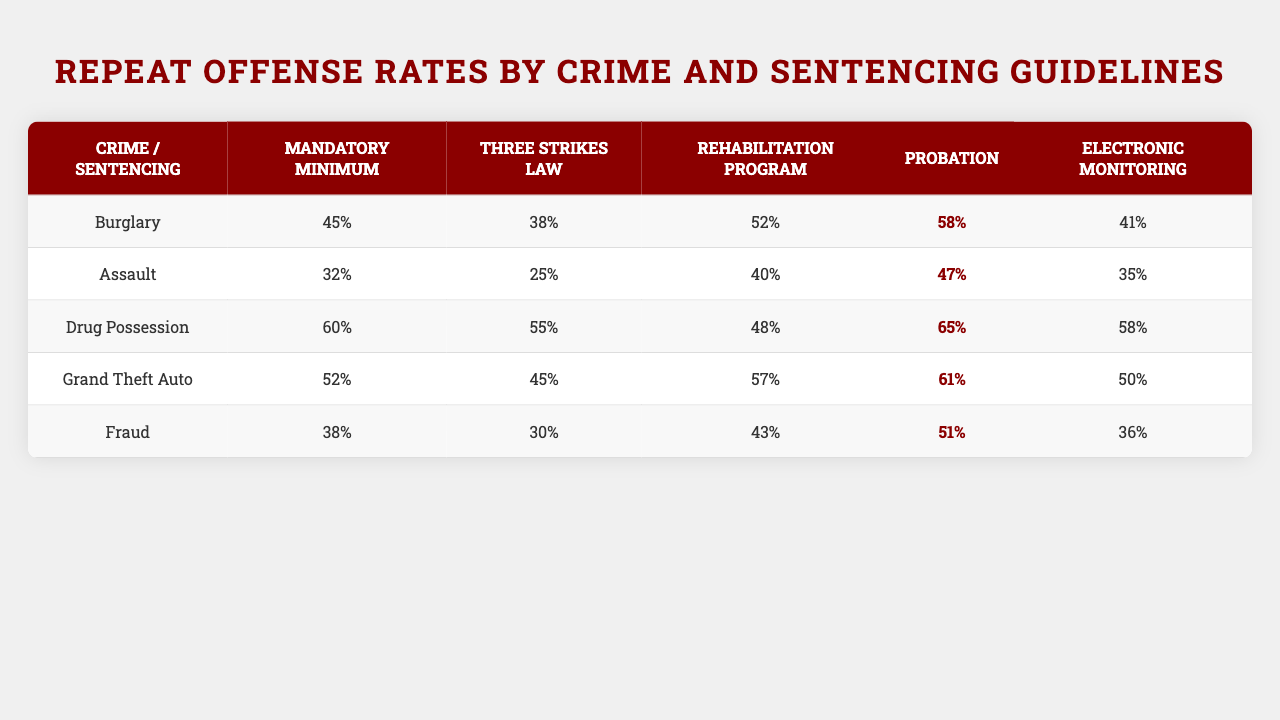What is the repeat offense rate for Burglary under Mandatory Minimum sentencing? Referring to the table, the repeat offense rate for Burglary is found under the column for Mandatory Minimum. The value is 45%.
Answer: 45% Which crime has the highest repeat offense rate under the Three Strikes Law? By examining the Three Strikes Law column, the crime with the highest repeat offense rate is Drug Possession, with a rate of 55%.
Answer: Drug Possession What is the average repeat offense rate for Grand Theft Auto across all sentencing guidelines? To find the average, sum the rates for Grand Theft Auto under all guidelines: (52 + 45 + 57 + 61 + 50) = 265. There are 5 rates, so the average is 265/5 = 53%.
Answer: 53% Is the repeat offense rate for Fraud higher under Electronic Monitoring than under Rehabilitation Program? For Fraud, under Rehabilitation Program the repeat offense rate is 51%, and under Electronic Monitoring it is 36%. Since 51% is greater than 36%, the answer is yes.
Answer: Yes Which sentencing guideline results in the lowest repeat offense rate for Assault? Looking at the Assault row, the lowest rate can be found in the Rehabilitation Program column, which shows a rate of 40%.
Answer: Rehabilitation Program What is the difference in repeat offense rates between Drug Possession and Grand Theft Auto under Probation? For Drug Possession under Probation, the rate is 65%, and for Grand Theft Auto it is 61%. The difference is 65 - 61 = 4%.
Answer: 4% Which crime shows the most variability in repeat offense rates across different sentencing guidelines? By analyzing the repeat offense rates, Drug Possession has rates ranging from 48% to 65%, showing a variability of 17%. This is larger than the variability noted in any other crime's rates.
Answer: Drug Possession What is the total repeat offense rate for Burglary under all sentencing guidelines? Summing the repeat offense rates for Burglary across all columns: (45 + 38 + 52 + 58 + 41) = 234.
Answer: 234 For which crime and sentencing guideline combination is the repeat offense rate equal to 32%? The repeat offense rate of 32% is specifically for Assault under Mandatory Minimum sentencing.
Answer: Assault / Mandatory Minimum 